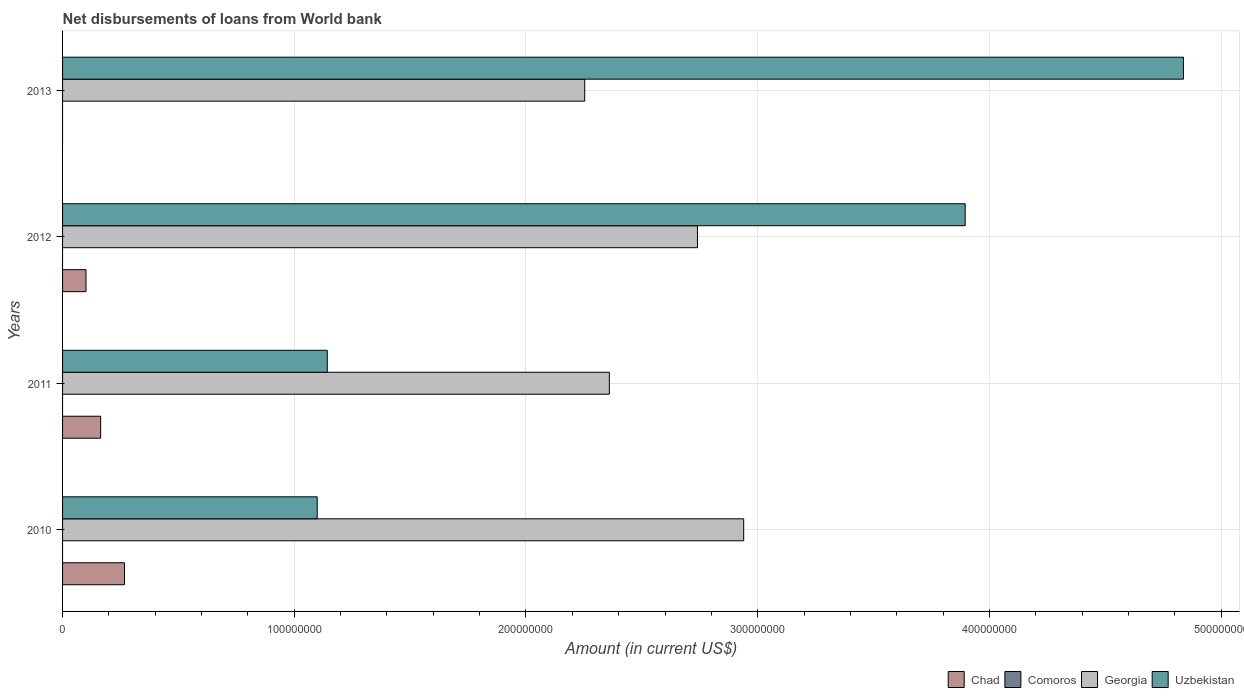How many different coloured bars are there?
Provide a short and direct response. 3. How many groups of bars are there?
Ensure brevity in your answer.  4. Are the number of bars on each tick of the Y-axis equal?
Ensure brevity in your answer.  No. How many bars are there on the 2nd tick from the top?
Give a very brief answer. 3. What is the amount of loan disbursed from World Bank in Uzbekistan in 2012?
Your answer should be compact. 3.90e+08. Across all years, what is the maximum amount of loan disbursed from World Bank in Chad?
Offer a terse response. 2.67e+07. Across all years, what is the minimum amount of loan disbursed from World Bank in Georgia?
Provide a succinct answer. 2.25e+08. In which year was the amount of loan disbursed from World Bank in Georgia maximum?
Provide a short and direct response. 2010. What is the total amount of loan disbursed from World Bank in Chad in the graph?
Provide a succinct answer. 5.33e+07. What is the difference between the amount of loan disbursed from World Bank in Uzbekistan in 2012 and that in 2013?
Your answer should be very brief. -9.42e+07. What is the difference between the amount of loan disbursed from World Bank in Georgia in 2011 and the amount of loan disbursed from World Bank in Uzbekistan in 2013?
Give a very brief answer. -2.48e+08. What is the average amount of loan disbursed from World Bank in Uzbekistan per year?
Keep it short and to the point. 2.74e+08. In the year 2013, what is the difference between the amount of loan disbursed from World Bank in Uzbekistan and amount of loan disbursed from World Bank in Georgia?
Give a very brief answer. 2.58e+08. What is the ratio of the amount of loan disbursed from World Bank in Georgia in 2011 to that in 2012?
Offer a very short reply. 0.86. Is the amount of loan disbursed from World Bank in Georgia in 2010 less than that in 2011?
Provide a succinct answer. No. Is the difference between the amount of loan disbursed from World Bank in Uzbekistan in 2012 and 2013 greater than the difference between the amount of loan disbursed from World Bank in Georgia in 2012 and 2013?
Offer a very short reply. No. What is the difference between the highest and the second highest amount of loan disbursed from World Bank in Chad?
Ensure brevity in your answer.  1.03e+07. What is the difference between the highest and the lowest amount of loan disbursed from World Bank in Chad?
Make the answer very short. 2.67e+07. In how many years, is the amount of loan disbursed from World Bank in Comoros greater than the average amount of loan disbursed from World Bank in Comoros taken over all years?
Ensure brevity in your answer.  0. How many bars are there?
Your response must be concise. 11. Are all the bars in the graph horizontal?
Keep it short and to the point. Yes. Does the graph contain grids?
Your answer should be compact. Yes. How many legend labels are there?
Provide a short and direct response. 4. How are the legend labels stacked?
Your response must be concise. Horizontal. What is the title of the graph?
Offer a very short reply. Net disbursements of loans from World bank. What is the label or title of the X-axis?
Your answer should be compact. Amount (in current US$). What is the label or title of the Y-axis?
Ensure brevity in your answer.  Years. What is the Amount (in current US$) of Chad in 2010?
Offer a terse response. 2.67e+07. What is the Amount (in current US$) in Georgia in 2010?
Make the answer very short. 2.94e+08. What is the Amount (in current US$) of Uzbekistan in 2010?
Your answer should be compact. 1.10e+08. What is the Amount (in current US$) in Chad in 2011?
Offer a very short reply. 1.64e+07. What is the Amount (in current US$) of Comoros in 2011?
Provide a short and direct response. 0. What is the Amount (in current US$) of Georgia in 2011?
Your answer should be compact. 2.36e+08. What is the Amount (in current US$) of Uzbekistan in 2011?
Provide a short and direct response. 1.14e+08. What is the Amount (in current US$) in Chad in 2012?
Make the answer very short. 1.01e+07. What is the Amount (in current US$) of Comoros in 2012?
Ensure brevity in your answer.  0. What is the Amount (in current US$) in Georgia in 2012?
Your response must be concise. 2.74e+08. What is the Amount (in current US$) in Uzbekistan in 2012?
Offer a terse response. 3.90e+08. What is the Amount (in current US$) in Chad in 2013?
Your answer should be very brief. 0. What is the Amount (in current US$) of Comoros in 2013?
Provide a short and direct response. 0. What is the Amount (in current US$) in Georgia in 2013?
Ensure brevity in your answer.  2.25e+08. What is the Amount (in current US$) of Uzbekistan in 2013?
Make the answer very short. 4.84e+08. Across all years, what is the maximum Amount (in current US$) in Chad?
Provide a succinct answer. 2.67e+07. Across all years, what is the maximum Amount (in current US$) of Georgia?
Ensure brevity in your answer.  2.94e+08. Across all years, what is the maximum Amount (in current US$) in Uzbekistan?
Keep it short and to the point. 4.84e+08. Across all years, what is the minimum Amount (in current US$) of Georgia?
Give a very brief answer. 2.25e+08. Across all years, what is the minimum Amount (in current US$) of Uzbekistan?
Your response must be concise. 1.10e+08. What is the total Amount (in current US$) in Chad in the graph?
Provide a short and direct response. 5.33e+07. What is the total Amount (in current US$) of Georgia in the graph?
Make the answer very short. 1.03e+09. What is the total Amount (in current US$) of Uzbekistan in the graph?
Provide a succinct answer. 1.10e+09. What is the difference between the Amount (in current US$) of Chad in 2010 and that in 2011?
Provide a short and direct response. 1.03e+07. What is the difference between the Amount (in current US$) of Georgia in 2010 and that in 2011?
Offer a terse response. 5.80e+07. What is the difference between the Amount (in current US$) in Uzbekistan in 2010 and that in 2011?
Your answer should be very brief. -4.34e+06. What is the difference between the Amount (in current US$) of Chad in 2010 and that in 2012?
Offer a terse response. 1.66e+07. What is the difference between the Amount (in current US$) in Georgia in 2010 and that in 2012?
Offer a very short reply. 1.99e+07. What is the difference between the Amount (in current US$) in Uzbekistan in 2010 and that in 2012?
Offer a terse response. -2.80e+08. What is the difference between the Amount (in current US$) of Georgia in 2010 and that in 2013?
Your answer should be compact. 6.86e+07. What is the difference between the Amount (in current US$) in Uzbekistan in 2010 and that in 2013?
Your answer should be very brief. -3.74e+08. What is the difference between the Amount (in current US$) in Chad in 2011 and that in 2012?
Your response must be concise. 6.32e+06. What is the difference between the Amount (in current US$) in Georgia in 2011 and that in 2012?
Offer a very short reply. -3.80e+07. What is the difference between the Amount (in current US$) in Uzbekistan in 2011 and that in 2012?
Give a very brief answer. -2.75e+08. What is the difference between the Amount (in current US$) of Georgia in 2011 and that in 2013?
Provide a short and direct response. 1.06e+07. What is the difference between the Amount (in current US$) in Uzbekistan in 2011 and that in 2013?
Provide a short and direct response. -3.70e+08. What is the difference between the Amount (in current US$) in Georgia in 2012 and that in 2013?
Your answer should be very brief. 4.87e+07. What is the difference between the Amount (in current US$) of Uzbekistan in 2012 and that in 2013?
Your response must be concise. -9.42e+07. What is the difference between the Amount (in current US$) of Chad in 2010 and the Amount (in current US$) of Georgia in 2011?
Provide a succinct answer. -2.09e+08. What is the difference between the Amount (in current US$) of Chad in 2010 and the Amount (in current US$) of Uzbekistan in 2011?
Provide a succinct answer. -8.75e+07. What is the difference between the Amount (in current US$) in Georgia in 2010 and the Amount (in current US$) in Uzbekistan in 2011?
Your response must be concise. 1.80e+08. What is the difference between the Amount (in current US$) in Chad in 2010 and the Amount (in current US$) in Georgia in 2012?
Provide a succinct answer. -2.47e+08. What is the difference between the Amount (in current US$) of Chad in 2010 and the Amount (in current US$) of Uzbekistan in 2012?
Give a very brief answer. -3.63e+08. What is the difference between the Amount (in current US$) in Georgia in 2010 and the Amount (in current US$) in Uzbekistan in 2012?
Your answer should be compact. -9.56e+07. What is the difference between the Amount (in current US$) of Chad in 2010 and the Amount (in current US$) of Georgia in 2013?
Offer a very short reply. -1.99e+08. What is the difference between the Amount (in current US$) in Chad in 2010 and the Amount (in current US$) in Uzbekistan in 2013?
Offer a very short reply. -4.57e+08. What is the difference between the Amount (in current US$) of Georgia in 2010 and the Amount (in current US$) of Uzbekistan in 2013?
Give a very brief answer. -1.90e+08. What is the difference between the Amount (in current US$) in Chad in 2011 and the Amount (in current US$) in Georgia in 2012?
Offer a terse response. -2.58e+08. What is the difference between the Amount (in current US$) in Chad in 2011 and the Amount (in current US$) in Uzbekistan in 2012?
Offer a very short reply. -3.73e+08. What is the difference between the Amount (in current US$) of Georgia in 2011 and the Amount (in current US$) of Uzbekistan in 2012?
Your answer should be very brief. -1.54e+08. What is the difference between the Amount (in current US$) in Chad in 2011 and the Amount (in current US$) in Georgia in 2013?
Ensure brevity in your answer.  -2.09e+08. What is the difference between the Amount (in current US$) of Chad in 2011 and the Amount (in current US$) of Uzbekistan in 2013?
Provide a short and direct response. -4.67e+08. What is the difference between the Amount (in current US$) of Georgia in 2011 and the Amount (in current US$) of Uzbekistan in 2013?
Make the answer very short. -2.48e+08. What is the difference between the Amount (in current US$) in Chad in 2012 and the Amount (in current US$) in Georgia in 2013?
Provide a succinct answer. -2.15e+08. What is the difference between the Amount (in current US$) of Chad in 2012 and the Amount (in current US$) of Uzbekistan in 2013?
Your answer should be very brief. -4.74e+08. What is the difference between the Amount (in current US$) in Georgia in 2012 and the Amount (in current US$) in Uzbekistan in 2013?
Offer a very short reply. -2.10e+08. What is the average Amount (in current US$) of Chad per year?
Give a very brief answer. 1.33e+07. What is the average Amount (in current US$) of Georgia per year?
Give a very brief answer. 2.57e+08. What is the average Amount (in current US$) of Uzbekistan per year?
Provide a succinct answer. 2.74e+08. In the year 2010, what is the difference between the Amount (in current US$) of Chad and Amount (in current US$) of Georgia?
Your response must be concise. -2.67e+08. In the year 2010, what is the difference between the Amount (in current US$) of Chad and Amount (in current US$) of Uzbekistan?
Your answer should be compact. -8.32e+07. In the year 2010, what is the difference between the Amount (in current US$) of Georgia and Amount (in current US$) of Uzbekistan?
Offer a very short reply. 1.84e+08. In the year 2011, what is the difference between the Amount (in current US$) in Chad and Amount (in current US$) in Georgia?
Ensure brevity in your answer.  -2.20e+08. In the year 2011, what is the difference between the Amount (in current US$) of Chad and Amount (in current US$) of Uzbekistan?
Give a very brief answer. -9.78e+07. In the year 2011, what is the difference between the Amount (in current US$) of Georgia and Amount (in current US$) of Uzbekistan?
Ensure brevity in your answer.  1.22e+08. In the year 2012, what is the difference between the Amount (in current US$) in Chad and Amount (in current US$) in Georgia?
Offer a terse response. -2.64e+08. In the year 2012, what is the difference between the Amount (in current US$) in Chad and Amount (in current US$) in Uzbekistan?
Keep it short and to the point. -3.79e+08. In the year 2012, what is the difference between the Amount (in current US$) of Georgia and Amount (in current US$) of Uzbekistan?
Your answer should be very brief. -1.16e+08. In the year 2013, what is the difference between the Amount (in current US$) in Georgia and Amount (in current US$) in Uzbekistan?
Ensure brevity in your answer.  -2.58e+08. What is the ratio of the Amount (in current US$) in Chad in 2010 to that in 2011?
Provide a succinct answer. 1.63. What is the ratio of the Amount (in current US$) in Georgia in 2010 to that in 2011?
Provide a short and direct response. 1.25. What is the ratio of the Amount (in current US$) of Chad in 2010 to that in 2012?
Provide a short and direct response. 2.64. What is the ratio of the Amount (in current US$) of Georgia in 2010 to that in 2012?
Your response must be concise. 1.07. What is the ratio of the Amount (in current US$) of Uzbekistan in 2010 to that in 2012?
Your response must be concise. 0.28. What is the ratio of the Amount (in current US$) of Georgia in 2010 to that in 2013?
Make the answer very short. 1.3. What is the ratio of the Amount (in current US$) in Uzbekistan in 2010 to that in 2013?
Provide a succinct answer. 0.23. What is the ratio of the Amount (in current US$) of Chad in 2011 to that in 2012?
Keep it short and to the point. 1.62. What is the ratio of the Amount (in current US$) in Georgia in 2011 to that in 2012?
Give a very brief answer. 0.86. What is the ratio of the Amount (in current US$) in Uzbekistan in 2011 to that in 2012?
Your response must be concise. 0.29. What is the ratio of the Amount (in current US$) in Georgia in 2011 to that in 2013?
Your response must be concise. 1.05. What is the ratio of the Amount (in current US$) of Uzbekistan in 2011 to that in 2013?
Make the answer very short. 0.24. What is the ratio of the Amount (in current US$) in Georgia in 2012 to that in 2013?
Provide a short and direct response. 1.22. What is the ratio of the Amount (in current US$) in Uzbekistan in 2012 to that in 2013?
Give a very brief answer. 0.81. What is the difference between the highest and the second highest Amount (in current US$) of Chad?
Keep it short and to the point. 1.03e+07. What is the difference between the highest and the second highest Amount (in current US$) of Georgia?
Keep it short and to the point. 1.99e+07. What is the difference between the highest and the second highest Amount (in current US$) in Uzbekistan?
Your answer should be very brief. 9.42e+07. What is the difference between the highest and the lowest Amount (in current US$) of Chad?
Keep it short and to the point. 2.67e+07. What is the difference between the highest and the lowest Amount (in current US$) of Georgia?
Give a very brief answer. 6.86e+07. What is the difference between the highest and the lowest Amount (in current US$) of Uzbekistan?
Provide a short and direct response. 3.74e+08. 